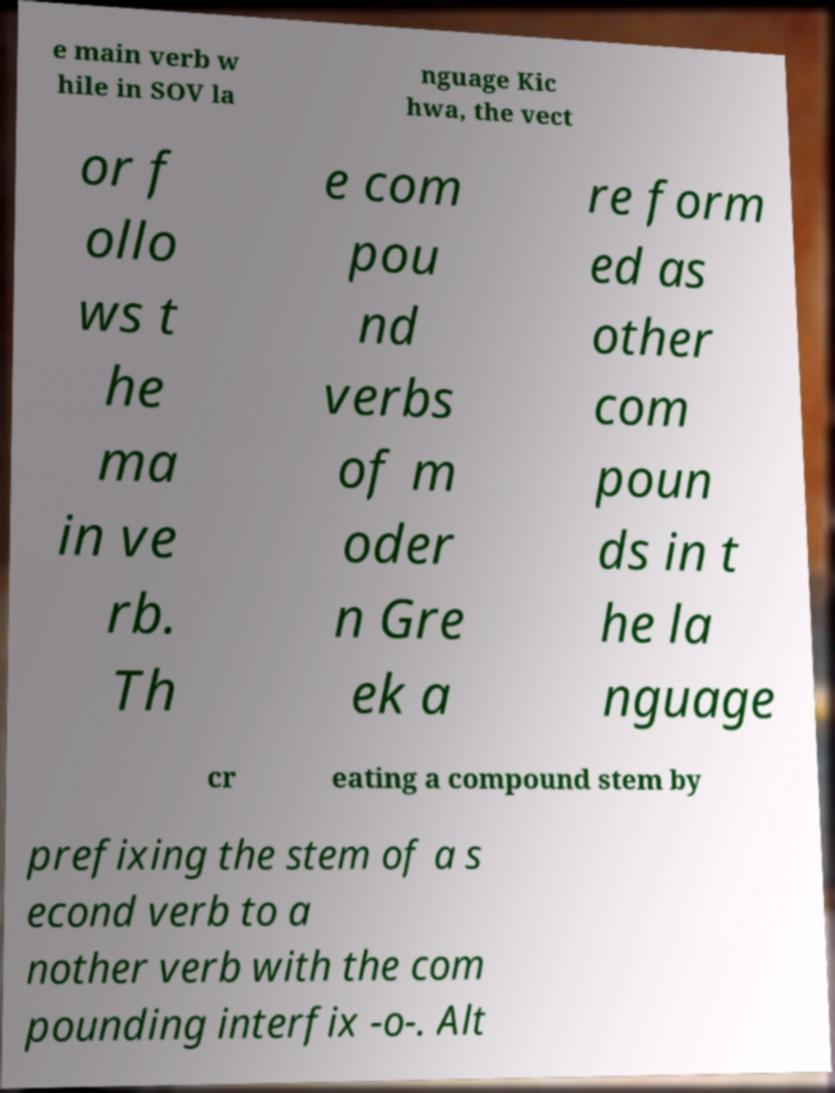I need the written content from this picture converted into text. Can you do that? e main verb w hile in SOV la nguage Kic hwa, the vect or f ollo ws t he ma in ve rb. Th e com pou nd verbs of m oder n Gre ek a re form ed as other com poun ds in t he la nguage cr eating a compound stem by prefixing the stem of a s econd verb to a nother verb with the com pounding interfix -o-. Alt 